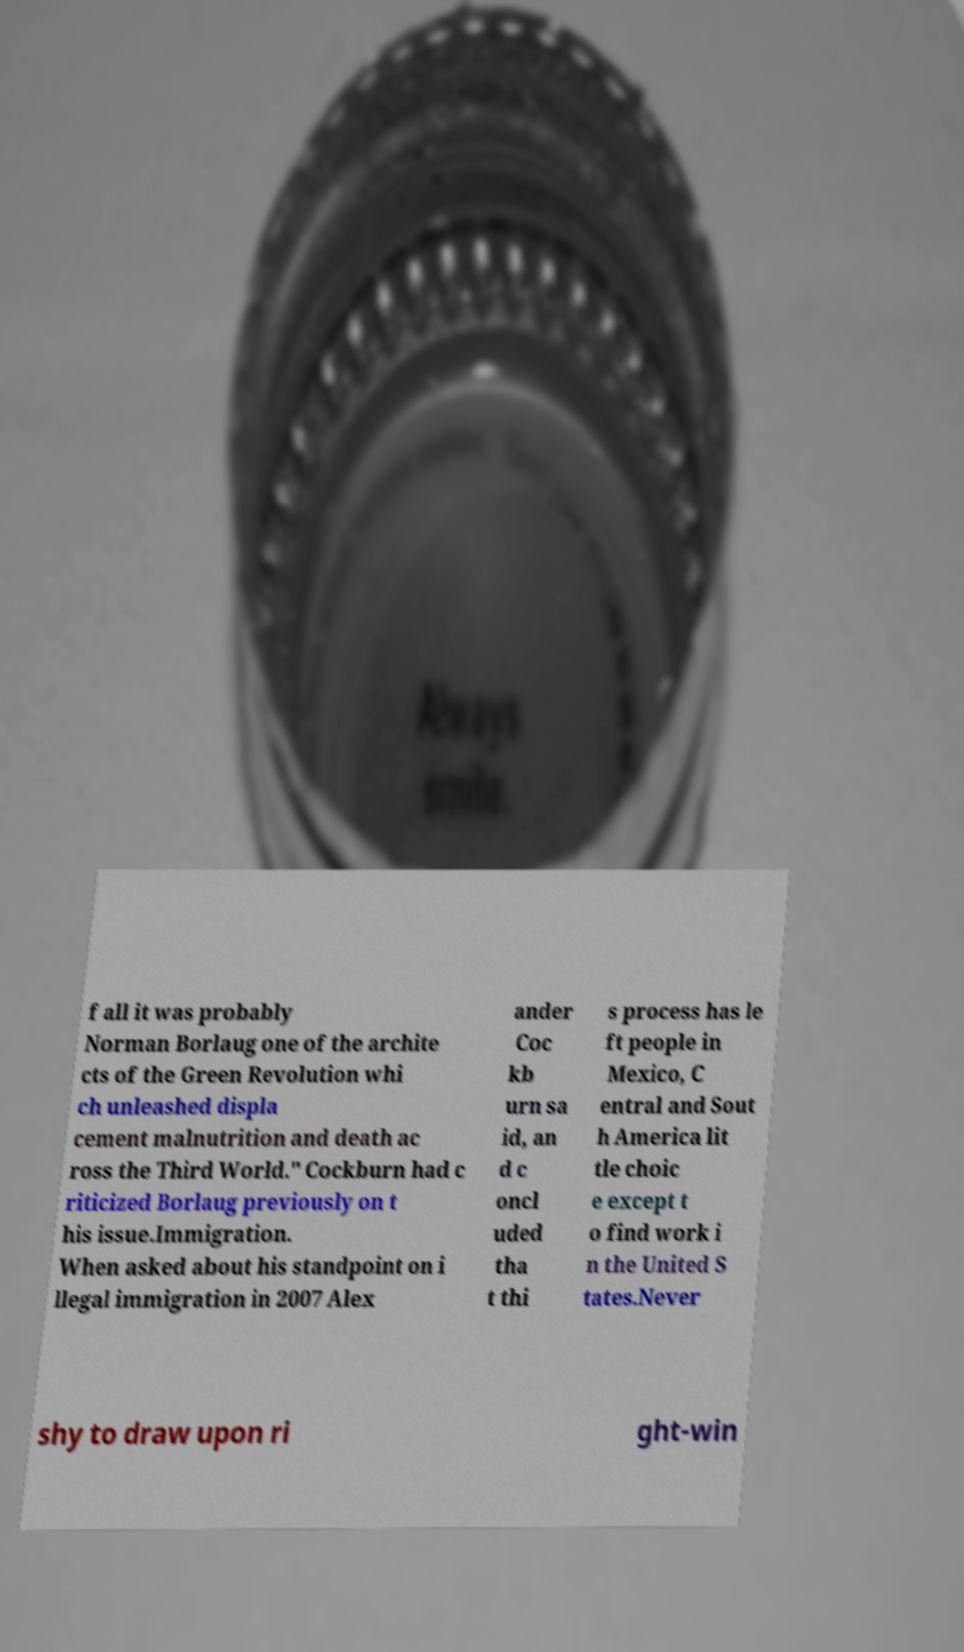I need the written content from this picture converted into text. Can you do that? f all it was probably Norman Borlaug one of the archite cts of the Green Revolution whi ch unleashed displa cement malnutrition and death ac ross the Third World." Cockburn had c riticized Borlaug previously on t his issue.Immigration. When asked about his standpoint on i llegal immigration in 2007 Alex ander Coc kb urn sa id, an d c oncl uded tha t thi s process has le ft people in Mexico, C entral and Sout h America lit tle choic e except t o find work i n the United S tates.Never shy to draw upon ri ght-win 